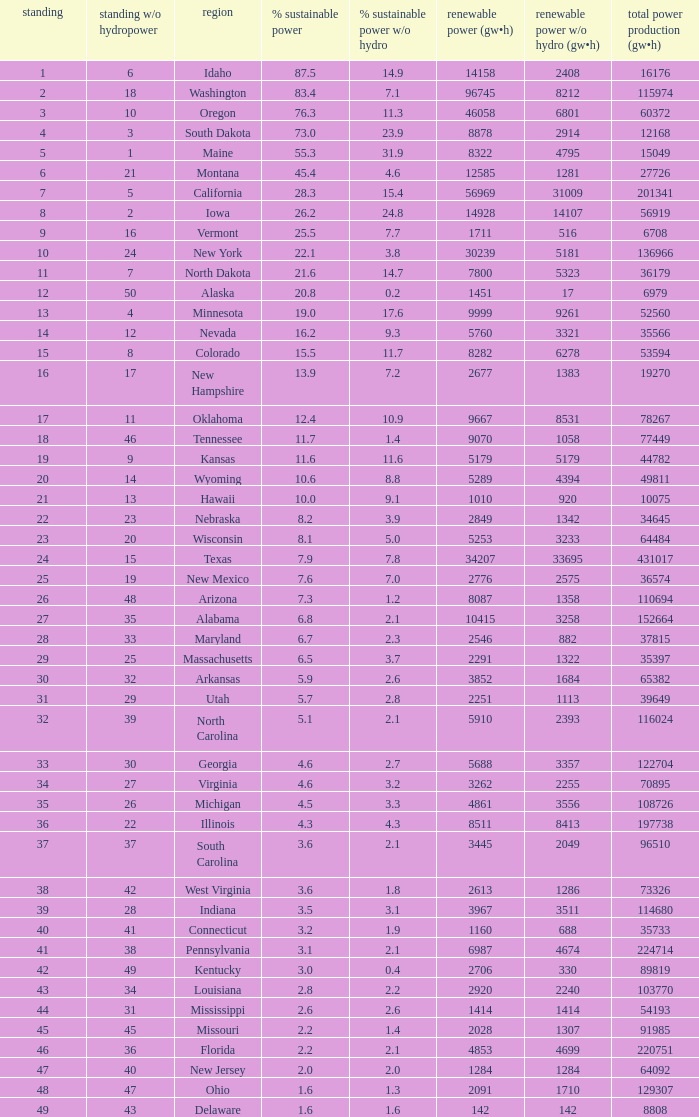What is the amount of renewable electricity without hydrogen power when the percentage of renewable energy is 83.4? 8212.0. 